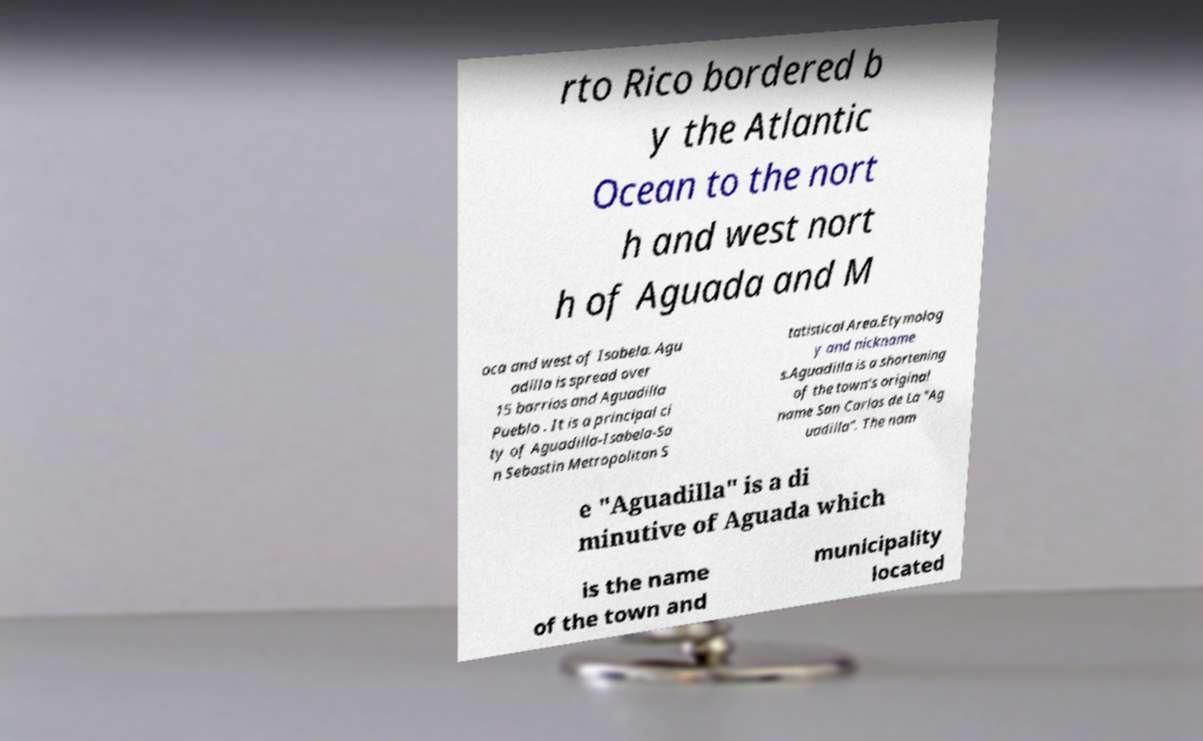There's text embedded in this image that I need extracted. Can you transcribe it verbatim? rto Rico bordered b y the Atlantic Ocean to the nort h and west nort h of Aguada and M oca and west of Isabela. Agu adilla is spread over 15 barrios and Aguadilla Pueblo . It is a principal ci ty of Aguadilla-Isabela-Sa n Sebastin Metropolitan S tatistical Area.Etymolog y and nickname s.Aguadilla is a shortening of the town's original name San Carlos de La "Ag uadilla". The nam e "Aguadilla" is a di minutive of Aguada which is the name of the town and municipality located 